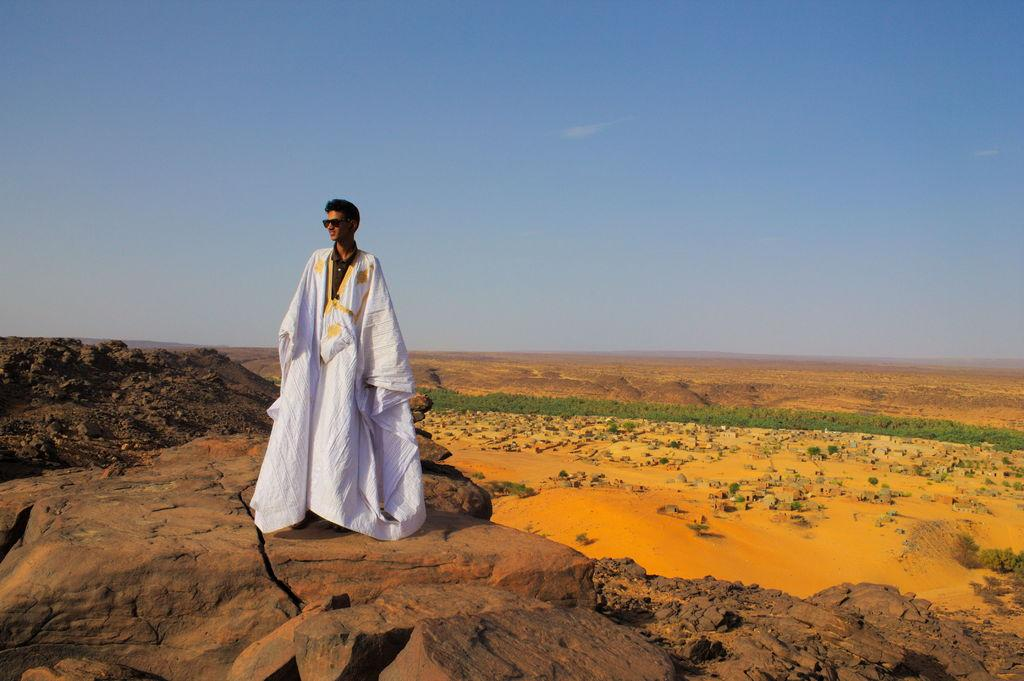What is the main subject of the image? There is a person in the image. What is the person wearing? The person is wearing a white dress. Where is the person standing? The person is standing on a rock. What is the rock surrounded by? The rock is surrounded by sand. What type of vegetation is near the rock? Small plants are present near the rock. What is the color of the sky in the image? The sky is blue. What type of sign can be seen near the person in the image? There is no sign present near the person in the image. What is the person wishing for while standing on the rock? There is no indication in the image that the person is wishing for anything. 